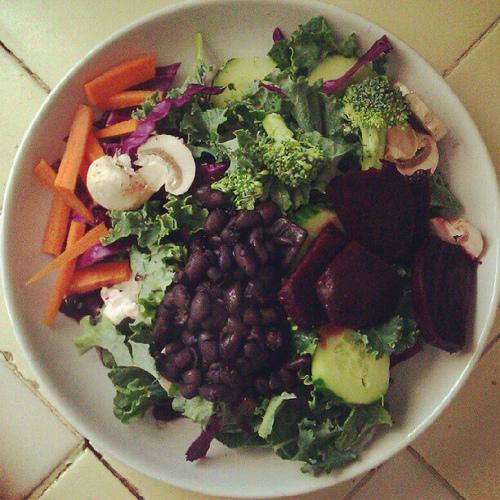Question: how is the purple cabbage sliced?
Choices:
A. Circled slices.
B. Chopped small.
C. Huge chunks.
D. Strips.
Answer with the letter. Answer: D Question: what is in the bowl?
Choices:
A. Spaghetti.
B. Chicken.
C. A salad.
D. Sandwich.
Answer with the letter. Answer: C Question: how many slices of beets?
Choices:
A. Twelve.
B. Fifteen.
C. Five.
D. Eight.
Answer with the letter. Answer: C Question: where are the carrots?
Choices:
A. On a shelve.
B. In the refrigderator.
C. Upper left.
D. On bottom.
Answer with the letter. Answer: C Question: what are the vegetables on top of?
Choices:
A. Pizza.
B. Hamburger.
C. Steak.
D. Lettuce.
Answer with the letter. Answer: D Question: where is the lettuce?
Choices:
A. Bottom of bowl.
B. Bottom of a plate.
C. In a bag.
D. In a box.
Answer with the letter. Answer: A 